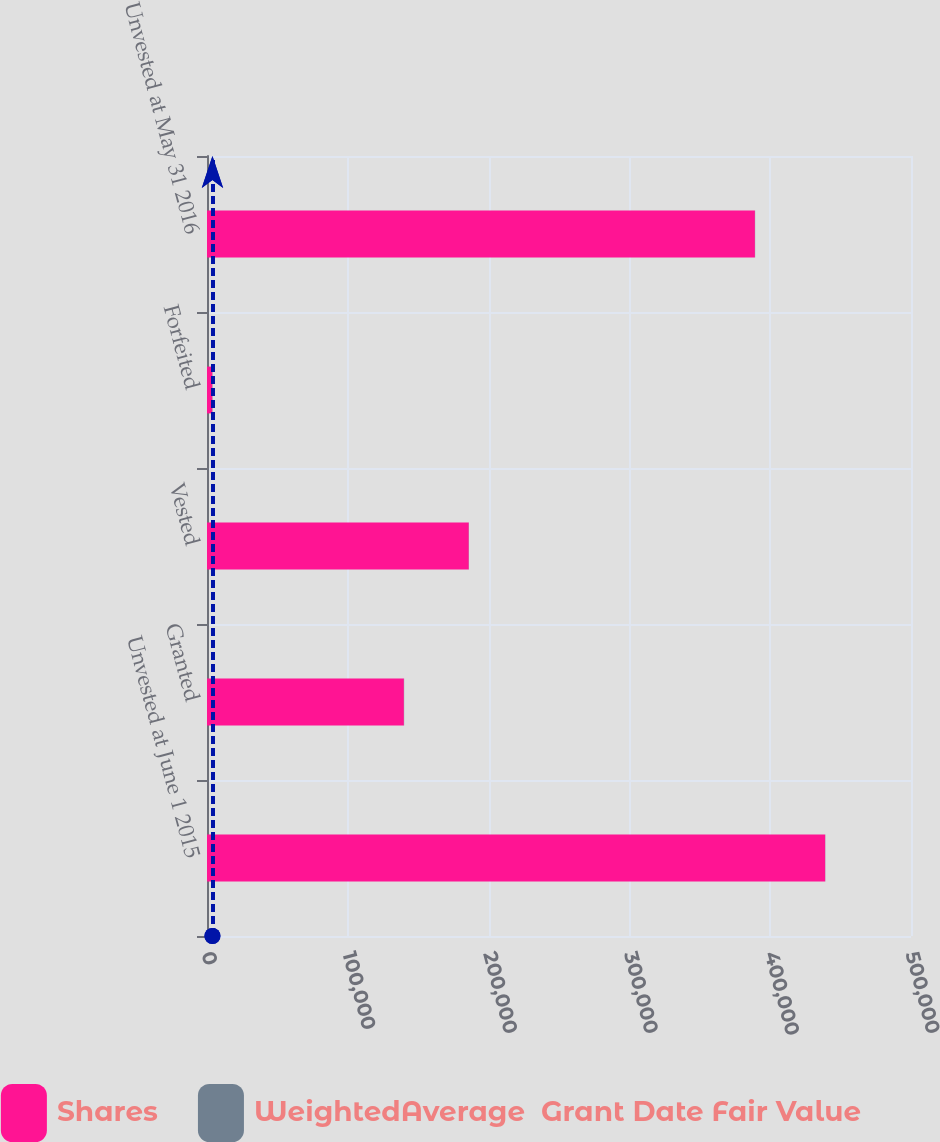Convert chart to OTSL. <chart><loc_0><loc_0><loc_500><loc_500><stacked_bar_chart><ecel><fcel>Unvested at June 1 2015<fcel>Granted<fcel>Vested<fcel>Forfeited<fcel>Unvested at May 31 2016<nl><fcel>Shares<fcel>439042<fcel>139838<fcel>185933<fcel>3795<fcel>389152<nl><fcel>WeightedAverage  Grant Date Fair Value<fcel>112.87<fcel>168.83<fcel>104.42<fcel>158.82<fcel>136.57<nl></chart> 